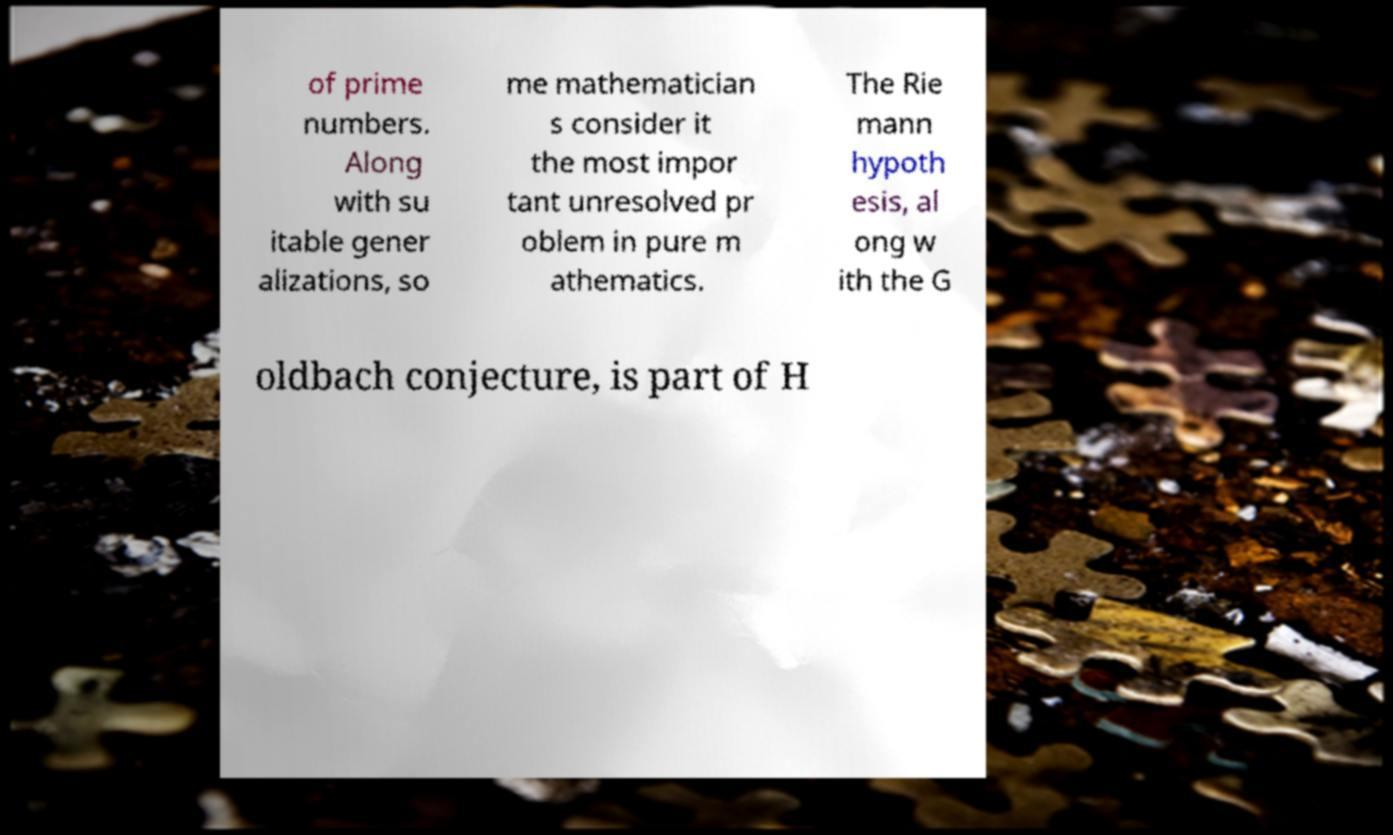Could you extract and type out the text from this image? of prime numbers. Along with su itable gener alizations, so me mathematician s consider it the most impor tant unresolved pr oblem in pure m athematics. The Rie mann hypoth esis, al ong w ith the G oldbach conjecture, is part of H 